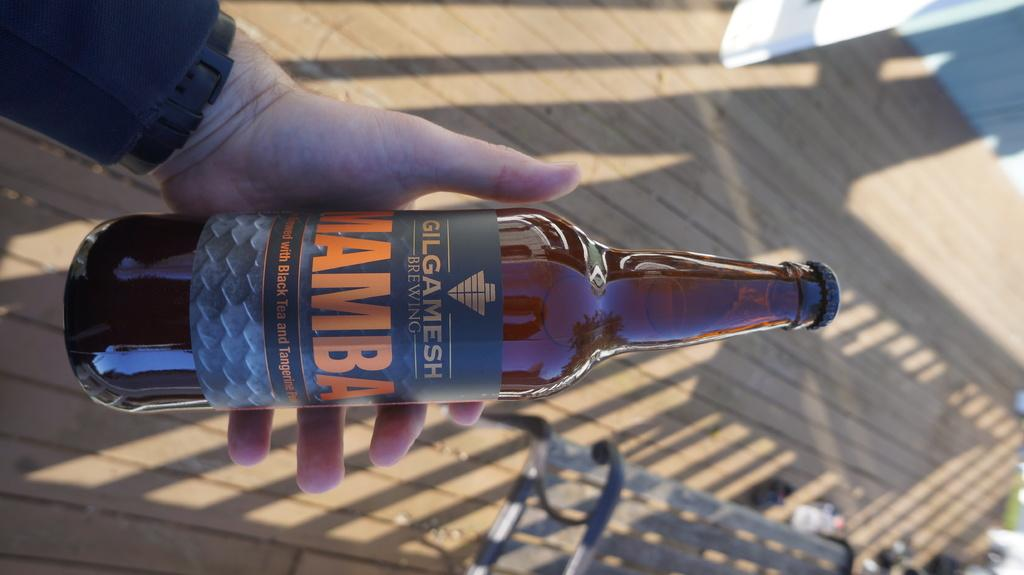What is the person in the image holding? The person is holding a bottle in the image. What can be seen to the right of the person? There is a bench to the right of the person. What type of flooring is visible in the background of the image? There is a wooden floor visible in the background of the image. What color is the zipper on the person's clothing in the image? There is no mention of a zipper on the person's clothing in the image, so we cannot determine its color. 